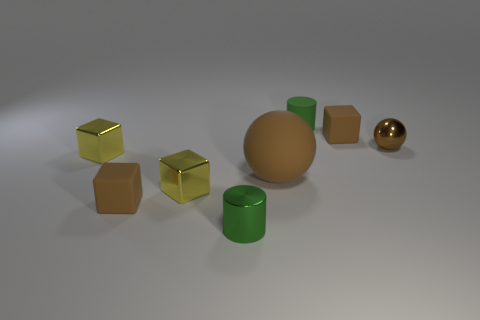Subtract all brown cubes. How many cubes are left? 2 Add 7 big brown rubber objects. How many big brown rubber objects are left? 8 Add 4 tiny brown metal balls. How many tiny brown metal balls exist? 5 Add 2 small yellow things. How many objects exist? 10 Subtract 0 blue balls. How many objects are left? 8 Subtract all balls. How many objects are left? 6 Subtract 2 balls. How many balls are left? 0 Subtract all cyan balls. Subtract all blue cylinders. How many balls are left? 2 Subtract all yellow spheres. How many brown blocks are left? 2 Subtract all green metallic cylinders. Subtract all yellow shiny objects. How many objects are left? 5 